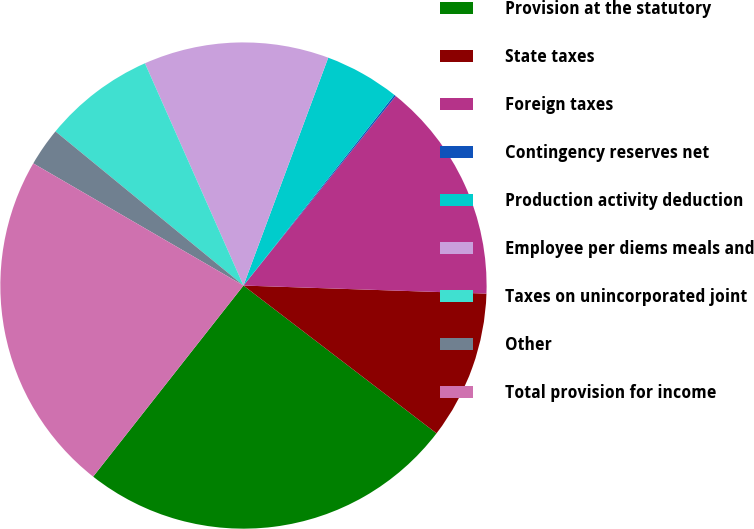<chart> <loc_0><loc_0><loc_500><loc_500><pie_chart><fcel>Provision at the statutory<fcel>State taxes<fcel>Foreign taxes<fcel>Contingency reserves net<fcel>Production activity deduction<fcel>Employee per diems meals and<fcel>Taxes on unincorporated joint<fcel>Other<fcel>Total provision for income<nl><fcel>25.21%<fcel>9.87%<fcel>14.76%<fcel>0.11%<fcel>4.99%<fcel>12.31%<fcel>7.43%<fcel>2.55%<fcel>22.77%<nl></chart> 